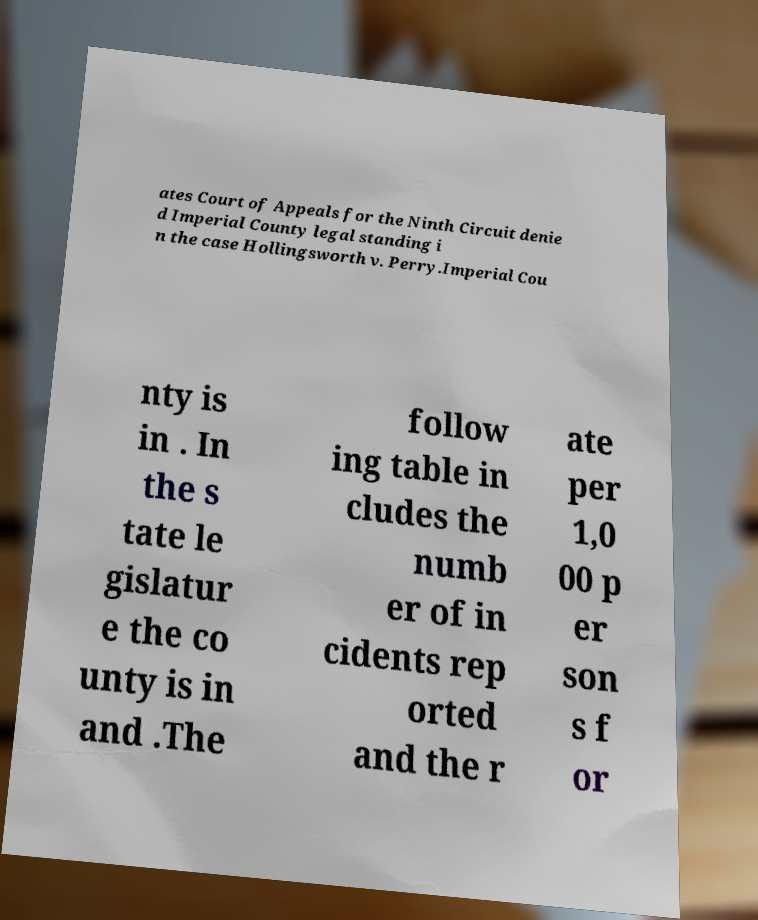There's text embedded in this image that I need extracted. Can you transcribe it verbatim? ates Court of Appeals for the Ninth Circuit denie d Imperial County legal standing i n the case Hollingsworth v. Perry.Imperial Cou nty is in . In the s tate le gislatur e the co unty is in and .The follow ing table in cludes the numb er of in cidents rep orted and the r ate per 1,0 00 p er son s f or 